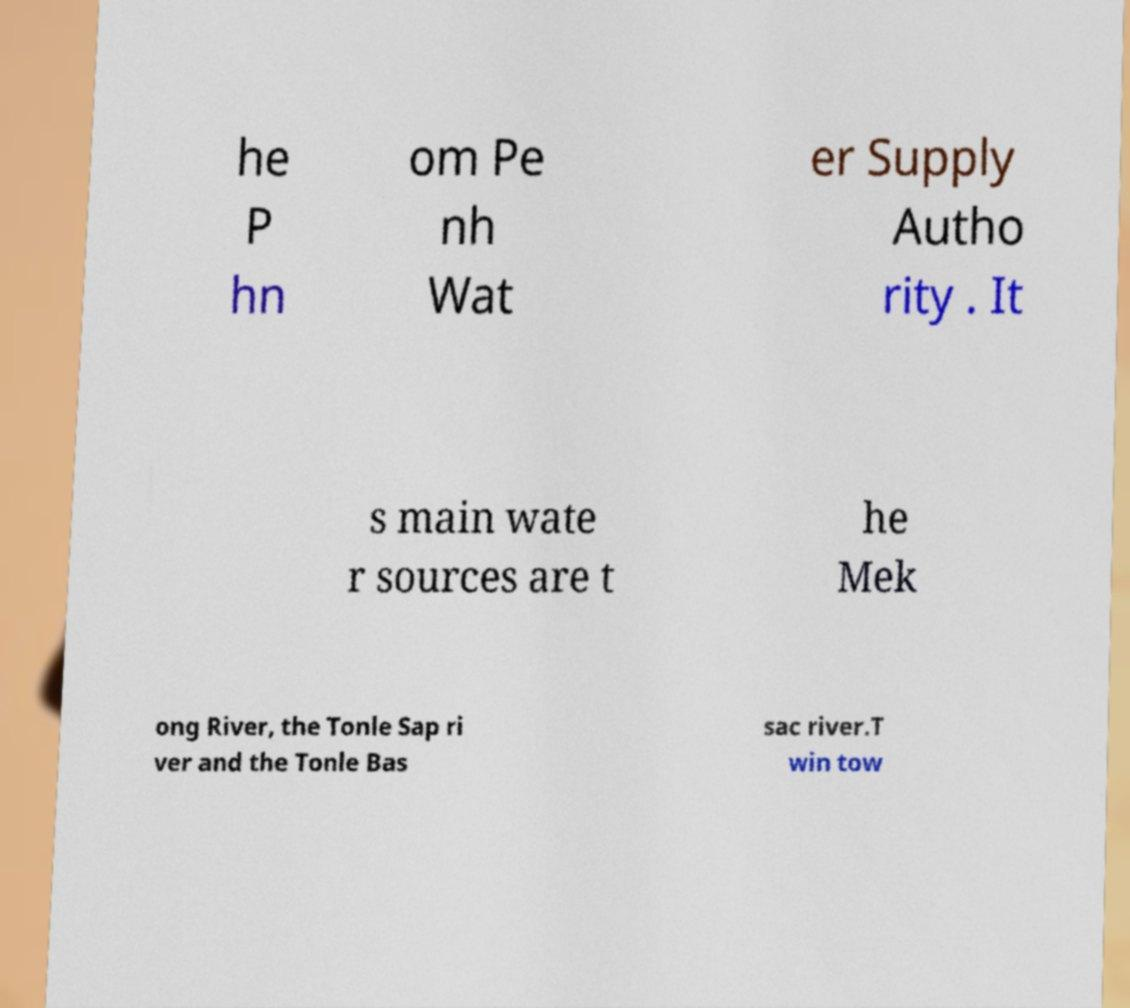Could you extract and type out the text from this image? he P hn om Pe nh Wat er Supply Autho rity . It s main wate r sources are t he Mek ong River, the Tonle Sap ri ver and the Tonle Bas sac river.T win tow 